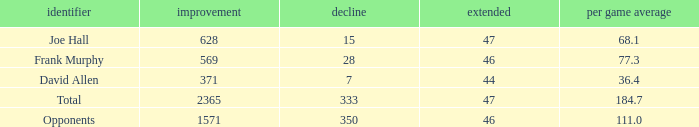How much Avg/G has a Gain smaller than 1571, and a Long smaller than 46? 1.0. 